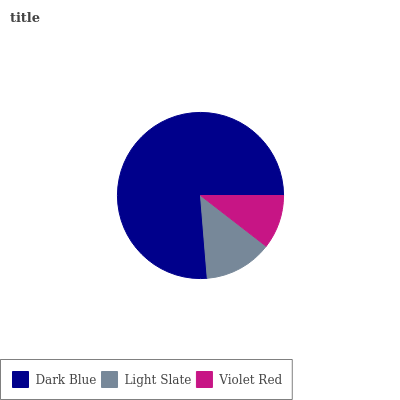Is Violet Red the minimum?
Answer yes or no. Yes. Is Dark Blue the maximum?
Answer yes or no. Yes. Is Light Slate the minimum?
Answer yes or no. No. Is Light Slate the maximum?
Answer yes or no. No. Is Dark Blue greater than Light Slate?
Answer yes or no. Yes. Is Light Slate less than Dark Blue?
Answer yes or no. Yes. Is Light Slate greater than Dark Blue?
Answer yes or no. No. Is Dark Blue less than Light Slate?
Answer yes or no. No. Is Light Slate the high median?
Answer yes or no. Yes. Is Light Slate the low median?
Answer yes or no. Yes. Is Violet Red the high median?
Answer yes or no. No. Is Violet Red the low median?
Answer yes or no. No. 